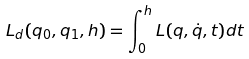<formula> <loc_0><loc_0><loc_500><loc_500>L _ { d } ( q _ { 0 } , q _ { 1 } , h ) = \int _ { 0 } ^ { h } L ( q , \dot { q } , t ) d t</formula> 